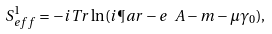Convert formula to latex. <formula><loc_0><loc_0><loc_500><loc_500>S ^ { 1 } _ { e f f } = - i T r \ln ( i \P a r - e \ A - m - \mu \gamma _ { 0 } ) ,</formula> 